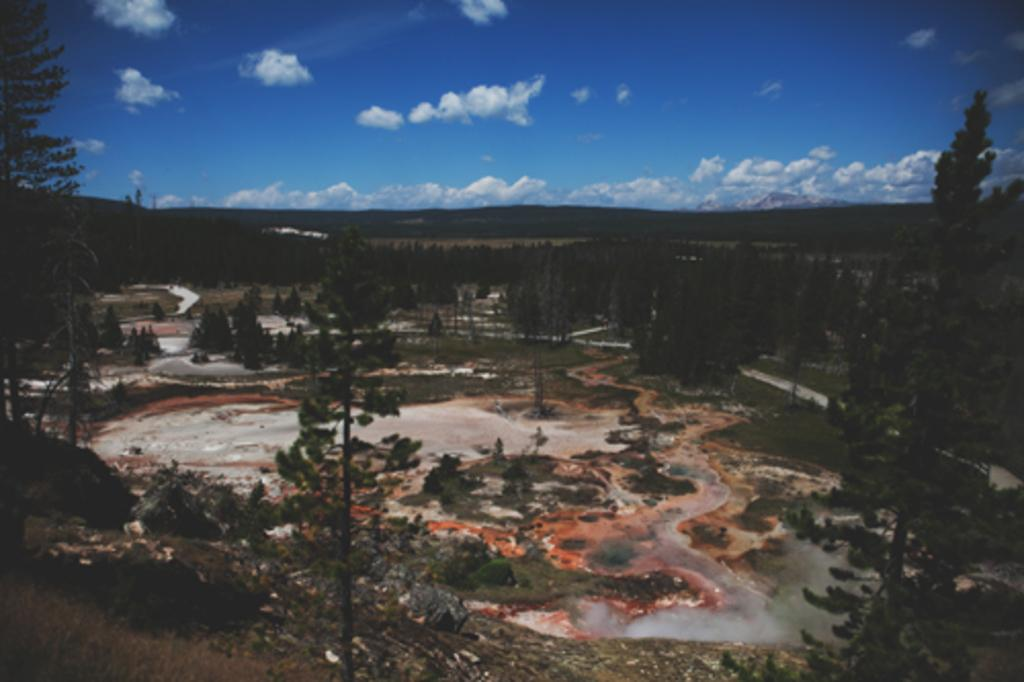What type of vegetation can be seen in the image? There are trees and plants in the image. What is visible in the background of the image? The sky is visible in the image. How would you describe the sky in the image? The sky appears to be cloudy in the image. What type of bed can be seen in the image? There is no bed present in the image; it features trees, plants, and a cloudy sky. What type of apparel is worn by the plants in the image? Plants do not wear apparel, so this question cannot be answered. 